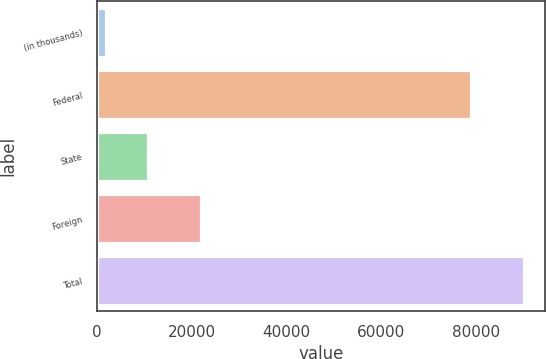<chart> <loc_0><loc_0><loc_500><loc_500><bar_chart><fcel>(in thousands)<fcel>Federal<fcel>State<fcel>Foreign<fcel>Total<nl><fcel>2012<fcel>79028<fcel>10817.2<fcel>22046<fcel>90064<nl></chart> 